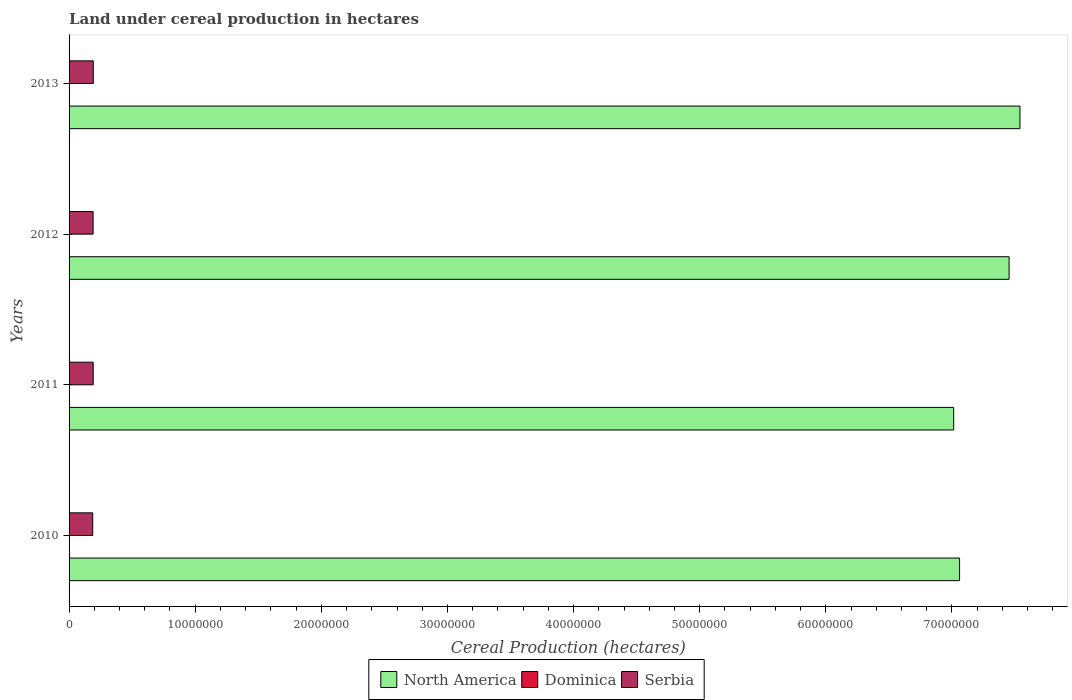How many different coloured bars are there?
Offer a terse response. 3. How many groups of bars are there?
Provide a short and direct response. 4. Are the number of bars per tick equal to the number of legend labels?
Provide a short and direct response. Yes. How many bars are there on the 4th tick from the top?
Your answer should be very brief. 3. How many bars are there on the 1st tick from the bottom?
Offer a very short reply. 3. In how many cases, is the number of bars for a given year not equal to the number of legend labels?
Offer a very short reply. 0. What is the land under cereal production in Serbia in 2010?
Your response must be concise. 1.87e+06. Across all years, what is the maximum land under cereal production in Dominica?
Provide a succinct answer. 120. Across all years, what is the minimum land under cereal production in Serbia?
Offer a terse response. 1.87e+06. In which year was the land under cereal production in Dominica minimum?
Your response must be concise. 2011. What is the total land under cereal production in Dominica in the graph?
Keep it short and to the point. 460. What is the difference between the land under cereal production in Serbia in 2010 and that in 2013?
Your response must be concise. -4.44e+04. What is the difference between the land under cereal production in Dominica in 2011 and the land under cereal production in North America in 2013?
Make the answer very short. -7.54e+07. What is the average land under cereal production in Serbia per year?
Make the answer very short. 1.90e+06. In the year 2012, what is the difference between the land under cereal production in North America and land under cereal production in Serbia?
Make the answer very short. 7.26e+07. In how many years, is the land under cereal production in Dominica greater than 36000000 hectares?
Offer a terse response. 0. What is the ratio of the land under cereal production in Serbia in 2012 to that in 2013?
Give a very brief answer. 0.99. What is the difference between the highest and the second highest land under cereal production in Dominica?
Your answer should be very brief. 0. What is the difference between the highest and the lowest land under cereal production in Serbia?
Offer a very short reply. 4.44e+04. What does the 2nd bar from the top in 2013 represents?
Give a very brief answer. Dominica. What does the 3rd bar from the bottom in 2010 represents?
Offer a very short reply. Serbia. Is it the case that in every year, the sum of the land under cereal production in North America and land under cereal production in Serbia is greater than the land under cereal production in Dominica?
Your answer should be compact. Yes. Are all the bars in the graph horizontal?
Provide a succinct answer. Yes. How many years are there in the graph?
Your answer should be compact. 4. What is the difference between two consecutive major ticks on the X-axis?
Offer a very short reply. 1.00e+07. Does the graph contain grids?
Make the answer very short. No. How are the legend labels stacked?
Your response must be concise. Horizontal. What is the title of the graph?
Keep it short and to the point. Land under cereal production in hectares. What is the label or title of the X-axis?
Provide a succinct answer. Cereal Production (hectares). What is the Cereal Production (hectares) in North America in 2010?
Make the answer very short. 7.06e+07. What is the Cereal Production (hectares) of Dominica in 2010?
Give a very brief answer. 120. What is the Cereal Production (hectares) in Serbia in 2010?
Offer a terse response. 1.87e+06. What is the Cereal Production (hectares) of North America in 2011?
Your response must be concise. 7.01e+07. What is the Cereal Production (hectares) of Serbia in 2011?
Your response must be concise. 1.91e+06. What is the Cereal Production (hectares) in North America in 2012?
Provide a short and direct response. 7.45e+07. What is the Cereal Production (hectares) of Dominica in 2012?
Offer a terse response. 120. What is the Cereal Production (hectares) of Serbia in 2012?
Keep it short and to the point. 1.90e+06. What is the Cereal Production (hectares) of North America in 2013?
Ensure brevity in your answer.  7.54e+07. What is the Cereal Production (hectares) in Dominica in 2013?
Your response must be concise. 120. What is the Cereal Production (hectares) of Serbia in 2013?
Your answer should be compact. 1.92e+06. Across all years, what is the maximum Cereal Production (hectares) in North America?
Give a very brief answer. 7.54e+07. Across all years, what is the maximum Cereal Production (hectares) of Dominica?
Your answer should be compact. 120. Across all years, what is the maximum Cereal Production (hectares) in Serbia?
Give a very brief answer. 1.92e+06. Across all years, what is the minimum Cereal Production (hectares) in North America?
Offer a very short reply. 7.01e+07. Across all years, what is the minimum Cereal Production (hectares) of Serbia?
Give a very brief answer. 1.87e+06. What is the total Cereal Production (hectares) in North America in the graph?
Offer a terse response. 2.91e+08. What is the total Cereal Production (hectares) of Dominica in the graph?
Provide a short and direct response. 460. What is the total Cereal Production (hectares) in Serbia in the graph?
Ensure brevity in your answer.  7.61e+06. What is the difference between the Cereal Production (hectares) of North America in 2010 and that in 2011?
Your response must be concise. 4.66e+05. What is the difference between the Cereal Production (hectares) in Dominica in 2010 and that in 2011?
Keep it short and to the point. 20. What is the difference between the Cereal Production (hectares) in Serbia in 2010 and that in 2011?
Give a very brief answer. -3.70e+04. What is the difference between the Cereal Production (hectares) in North America in 2010 and that in 2012?
Keep it short and to the point. -3.93e+06. What is the difference between the Cereal Production (hectares) in Serbia in 2010 and that in 2012?
Offer a terse response. -2.98e+04. What is the difference between the Cereal Production (hectares) in North America in 2010 and that in 2013?
Your answer should be very brief. -4.79e+06. What is the difference between the Cereal Production (hectares) in Serbia in 2010 and that in 2013?
Provide a short and direct response. -4.44e+04. What is the difference between the Cereal Production (hectares) of North America in 2011 and that in 2012?
Offer a very short reply. -4.39e+06. What is the difference between the Cereal Production (hectares) of Dominica in 2011 and that in 2012?
Provide a succinct answer. -20. What is the difference between the Cereal Production (hectares) of Serbia in 2011 and that in 2012?
Ensure brevity in your answer.  7254. What is the difference between the Cereal Production (hectares) in North America in 2011 and that in 2013?
Offer a terse response. -5.25e+06. What is the difference between the Cereal Production (hectares) in Dominica in 2011 and that in 2013?
Ensure brevity in your answer.  -20. What is the difference between the Cereal Production (hectares) in Serbia in 2011 and that in 2013?
Offer a very short reply. -7399. What is the difference between the Cereal Production (hectares) of North America in 2012 and that in 2013?
Offer a very short reply. -8.60e+05. What is the difference between the Cereal Production (hectares) of Serbia in 2012 and that in 2013?
Give a very brief answer. -1.47e+04. What is the difference between the Cereal Production (hectares) of North America in 2010 and the Cereal Production (hectares) of Dominica in 2011?
Your answer should be very brief. 7.06e+07. What is the difference between the Cereal Production (hectares) of North America in 2010 and the Cereal Production (hectares) of Serbia in 2011?
Give a very brief answer. 6.87e+07. What is the difference between the Cereal Production (hectares) in Dominica in 2010 and the Cereal Production (hectares) in Serbia in 2011?
Your response must be concise. -1.91e+06. What is the difference between the Cereal Production (hectares) of North America in 2010 and the Cereal Production (hectares) of Dominica in 2012?
Ensure brevity in your answer.  7.06e+07. What is the difference between the Cereal Production (hectares) in North America in 2010 and the Cereal Production (hectares) in Serbia in 2012?
Ensure brevity in your answer.  6.87e+07. What is the difference between the Cereal Production (hectares) of Dominica in 2010 and the Cereal Production (hectares) of Serbia in 2012?
Offer a terse response. -1.90e+06. What is the difference between the Cereal Production (hectares) in North America in 2010 and the Cereal Production (hectares) in Dominica in 2013?
Keep it short and to the point. 7.06e+07. What is the difference between the Cereal Production (hectares) of North America in 2010 and the Cereal Production (hectares) of Serbia in 2013?
Keep it short and to the point. 6.87e+07. What is the difference between the Cereal Production (hectares) in Dominica in 2010 and the Cereal Production (hectares) in Serbia in 2013?
Your answer should be very brief. -1.92e+06. What is the difference between the Cereal Production (hectares) of North America in 2011 and the Cereal Production (hectares) of Dominica in 2012?
Your response must be concise. 7.01e+07. What is the difference between the Cereal Production (hectares) in North America in 2011 and the Cereal Production (hectares) in Serbia in 2012?
Provide a short and direct response. 6.82e+07. What is the difference between the Cereal Production (hectares) of Dominica in 2011 and the Cereal Production (hectares) of Serbia in 2012?
Keep it short and to the point. -1.90e+06. What is the difference between the Cereal Production (hectares) in North America in 2011 and the Cereal Production (hectares) in Dominica in 2013?
Keep it short and to the point. 7.01e+07. What is the difference between the Cereal Production (hectares) in North America in 2011 and the Cereal Production (hectares) in Serbia in 2013?
Provide a succinct answer. 6.82e+07. What is the difference between the Cereal Production (hectares) in Dominica in 2011 and the Cereal Production (hectares) in Serbia in 2013?
Ensure brevity in your answer.  -1.92e+06. What is the difference between the Cereal Production (hectares) in North America in 2012 and the Cereal Production (hectares) in Dominica in 2013?
Ensure brevity in your answer.  7.45e+07. What is the difference between the Cereal Production (hectares) in North America in 2012 and the Cereal Production (hectares) in Serbia in 2013?
Offer a terse response. 7.26e+07. What is the difference between the Cereal Production (hectares) in Dominica in 2012 and the Cereal Production (hectares) in Serbia in 2013?
Keep it short and to the point. -1.92e+06. What is the average Cereal Production (hectares) of North America per year?
Your answer should be very brief. 7.27e+07. What is the average Cereal Production (hectares) of Dominica per year?
Give a very brief answer. 115. What is the average Cereal Production (hectares) in Serbia per year?
Offer a terse response. 1.90e+06. In the year 2010, what is the difference between the Cereal Production (hectares) in North America and Cereal Production (hectares) in Dominica?
Your answer should be compact. 7.06e+07. In the year 2010, what is the difference between the Cereal Production (hectares) in North America and Cereal Production (hectares) in Serbia?
Offer a very short reply. 6.87e+07. In the year 2010, what is the difference between the Cereal Production (hectares) of Dominica and Cereal Production (hectares) of Serbia?
Offer a very short reply. -1.87e+06. In the year 2011, what is the difference between the Cereal Production (hectares) in North America and Cereal Production (hectares) in Dominica?
Your response must be concise. 7.01e+07. In the year 2011, what is the difference between the Cereal Production (hectares) in North America and Cereal Production (hectares) in Serbia?
Offer a terse response. 6.82e+07. In the year 2011, what is the difference between the Cereal Production (hectares) in Dominica and Cereal Production (hectares) in Serbia?
Provide a succinct answer. -1.91e+06. In the year 2012, what is the difference between the Cereal Production (hectares) in North America and Cereal Production (hectares) in Dominica?
Your response must be concise. 7.45e+07. In the year 2012, what is the difference between the Cereal Production (hectares) in North America and Cereal Production (hectares) in Serbia?
Provide a succinct answer. 7.26e+07. In the year 2012, what is the difference between the Cereal Production (hectares) of Dominica and Cereal Production (hectares) of Serbia?
Your answer should be very brief. -1.90e+06. In the year 2013, what is the difference between the Cereal Production (hectares) in North America and Cereal Production (hectares) in Dominica?
Offer a very short reply. 7.54e+07. In the year 2013, what is the difference between the Cereal Production (hectares) of North America and Cereal Production (hectares) of Serbia?
Your answer should be very brief. 7.35e+07. In the year 2013, what is the difference between the Cereal Production (hectares) of Dominica and Cereal Production (hectares) of Serbia?
Make the answer very short. -1.92e+06. What is the ratio of the Cereal Production (hectares) of North America in 2010 to that in 2011?
Your answer should be compact. 1.01. What is the ratio of the Cereal Production (hectares) in Serbia in 2010 to that in 2011?
Ensure brevity in your answer.  0.98. What is the ratio of the Cereal Production (hectares) in North America in 2010 to that in 2012?
Your response must be concise. 0.95. What is the ratio of the Cereal Production (hectares) in Dominica in 2010 to that in 2012?
Ensure brevity in your answer.  1. What is the ratio of the Cereal Production (hectares) of Serbia in 2010 to that in 2012?
Provide a succinct answer. 0.98. What is the ratio of the Cereal Production (hectares) in North America in 2010 to that in 2013?
Ensure brevity in your answer.  0.94. What is the ratio of the Cereal Production (hectares) in Serbia in 2010 to that in 2013?
Provide a short and direct response. 0.98. What is the ratio of the Cereal Production (hectares) in North America in 2011 to that in 2012?
Your response must be concise. 0.94. What is the ratio of the Cereal Production (hectares) in Serbia in 2011 to that in 2012?
Your answer should be compact. 1. What is the ratio of the Cereal Production (hectares) in North America in 2011 to that in 2013?
Your answer should be very brief. 0.93. What is the ratio of the Cereal Production (hectares) in Dominica in 2011 to that in 2013?
Give a very brief answer. 0.83. What is the ratio of the Cereal Production (hectares) in Serbia in 2011 to that in 2013?
Make the answer very short. 1. What is the ratio of the Cereal Production (hectares) in Serbia in 2012 to that in 2013?
Give a very brief answer. 0.99. What is the difference between the highest and the second highest Cereal Production (hectares) of North America?
Provide a succinct answer. 8.60e+05. What is the difference between the highest and the second highest Cereal Production (hectares) of Dominica?
Offer a very short reply. 0. What is the difference between the highest and the second highest Cereal Production (hectares) of Serbia?
Provide a succinct answer. 7399. What is the difference between the highest and the lowest Cereal Production (hectares) of North America?
Ensure brevity in your answer.  5.25e+06. What is the difference between the highest and the lowest Cereal Production (hectares) of Dominica?
Your answer should be very brief. 20. What is the difference between the highest and the lowest Cereal Production (hectares) in Serbia?
Ensure brevity in your answer.  4.44e+04. 